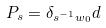<formula> <loc_0><loc_0><loc_500><loc_500>P _ { s } = \delta _ { s ^ { - 1 } w _ { 0 } } d</formula> 